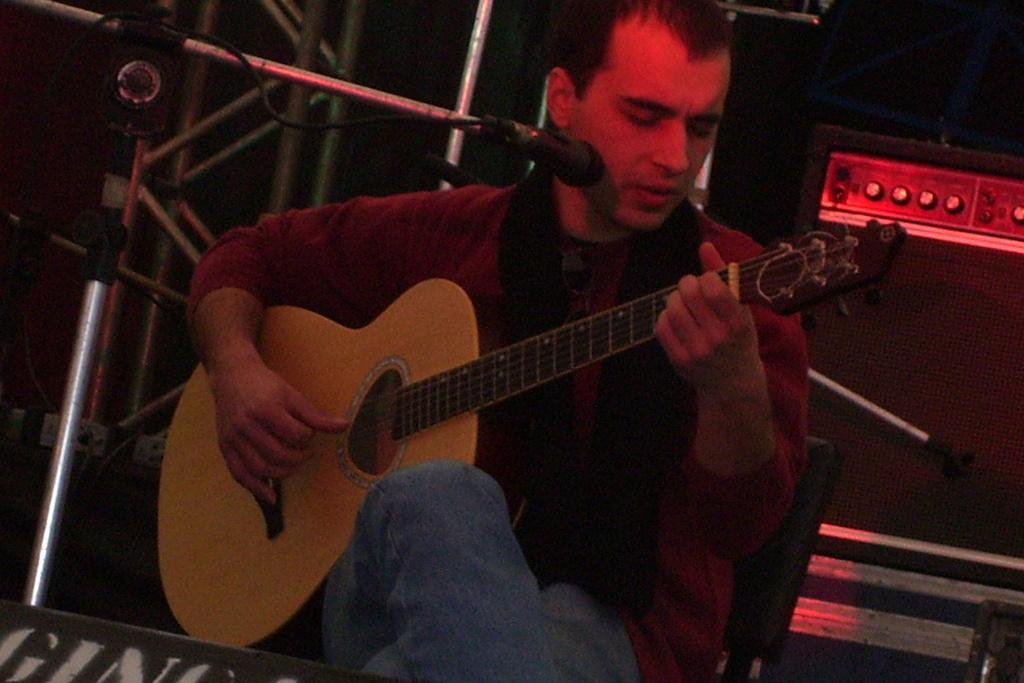Please provide a concise description of this image. In this image there is a man sitting and playing a guitar. He is also singing. To the left there is mic stand along with mic. In the background there is a speaker. 